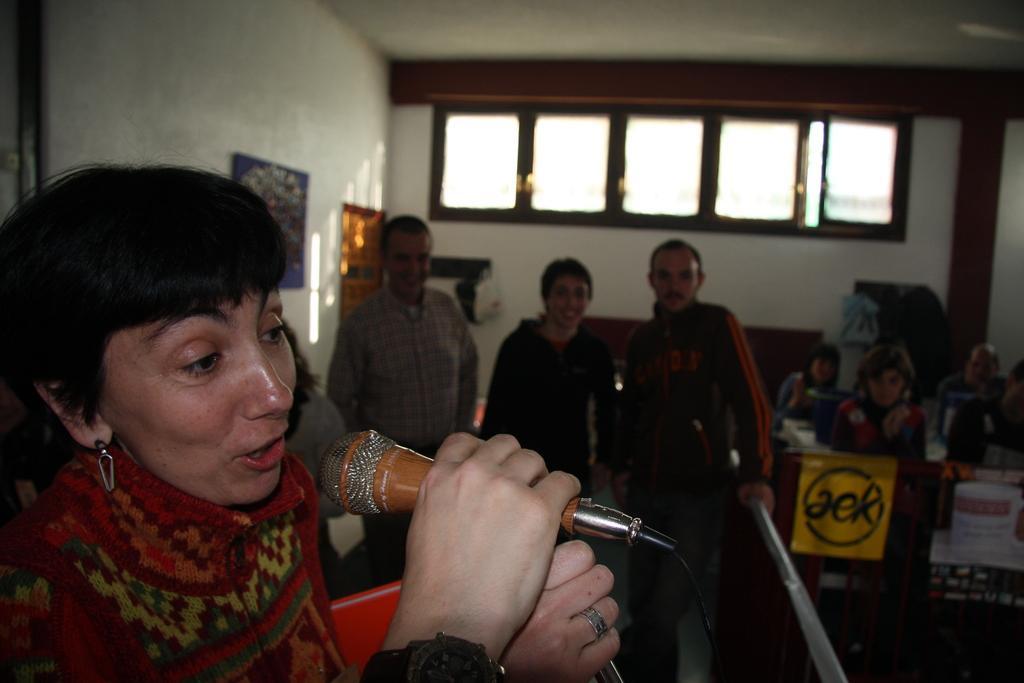Please provide a concise description of this image. This image is clicked in a room. There are Windows on the backside, there are some people sitting on the right side. There are people stand, three people standing in the middle. One of one one, woman who is standing on the left side is holding mic in her hand. There are photo frames on the wall. 